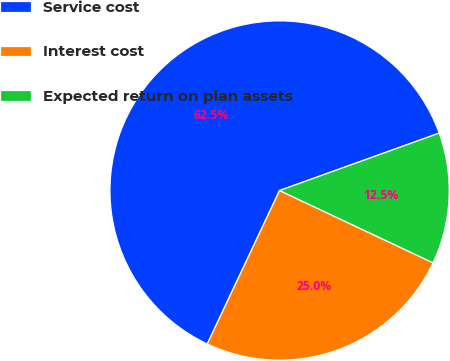Convert chart. <chart><loc_0><loc_0><loc_500><loc_500><pie_chart><fcel>Service cost<fcel>Interest cost<fcel>Expected return on plan assets<nl><fcel>62.5%<fcel>25.0%<fcel>12.5%<nl></chart> 